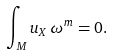<formula> <loc_0><loc_0><loc_500><loc_500>\int _ { M } u _ { X } \, \omega ^ { m } = 0 .</formula> 